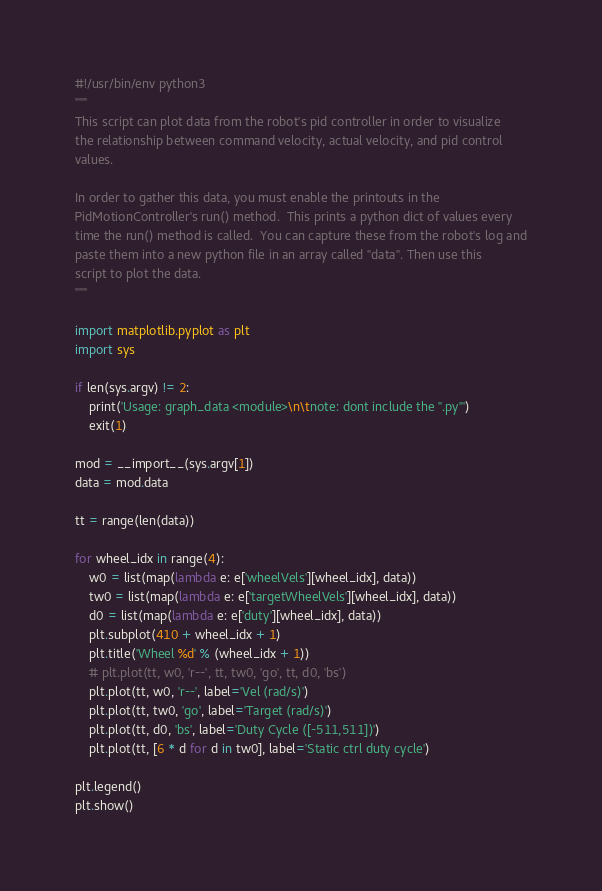Convert code to text. <code><loc_0><loc_0><loc_500><loc_500><_Python_>#!/usr/bin/env python3
"""
This script can plot data from the robot's pid controller in order to visualize
the relationship between command velocity, actual velocity, and pid control
values.

In order to gather this data, you must enable the printouts in the
PidMotionController's run() method.  This prints a python dict of values every
time the run() method is called.  You can capture these from the robot's log and
paste them into a new python file in an array called "data". Then use this
script to plot the data.
"""

import matplotlib.pyplot as plt
import sys

if len(sys.argv) != 2:
    print('Usage: graph_data <module>\n\tnote: dont include the ".py"')
    exit(1)

mod = __import__(sys.argv[1])
data = mod.data

tt = range(len(data))

for wheel_idx in range(4):
    w0 = list(map(lambda e: e['wheelVels'][wheel_idx], data))
    tw0 = list(map(lambda e: e['targetWheelVels'][wheel_idx], data))
    d0 = list(map(lambda e: e['duty'][wheel_idx], data))
    plt.subplot(410 + wheel_idx + 1)
    plt.title('Wheel %d' % (wheel_idx + 1))
    # plt.plot(tt, w0, 'r--', tt, tw0, 'go', tt, d0, 'bs')
    plt.plot(tt, w0, 'r--', label='Vel (rad/s)')
    plt.plot(tt, tw0, 'go', label='Target (rad/s)')
    plt.plot(tt, d0, 'bs', label='Duty Cycle ([-511,511])')
    plt.plot(tt, [6 * d for d in tw0], label='Static ctrl duty cycle')

plt.legend()
plt.show()
</code> 